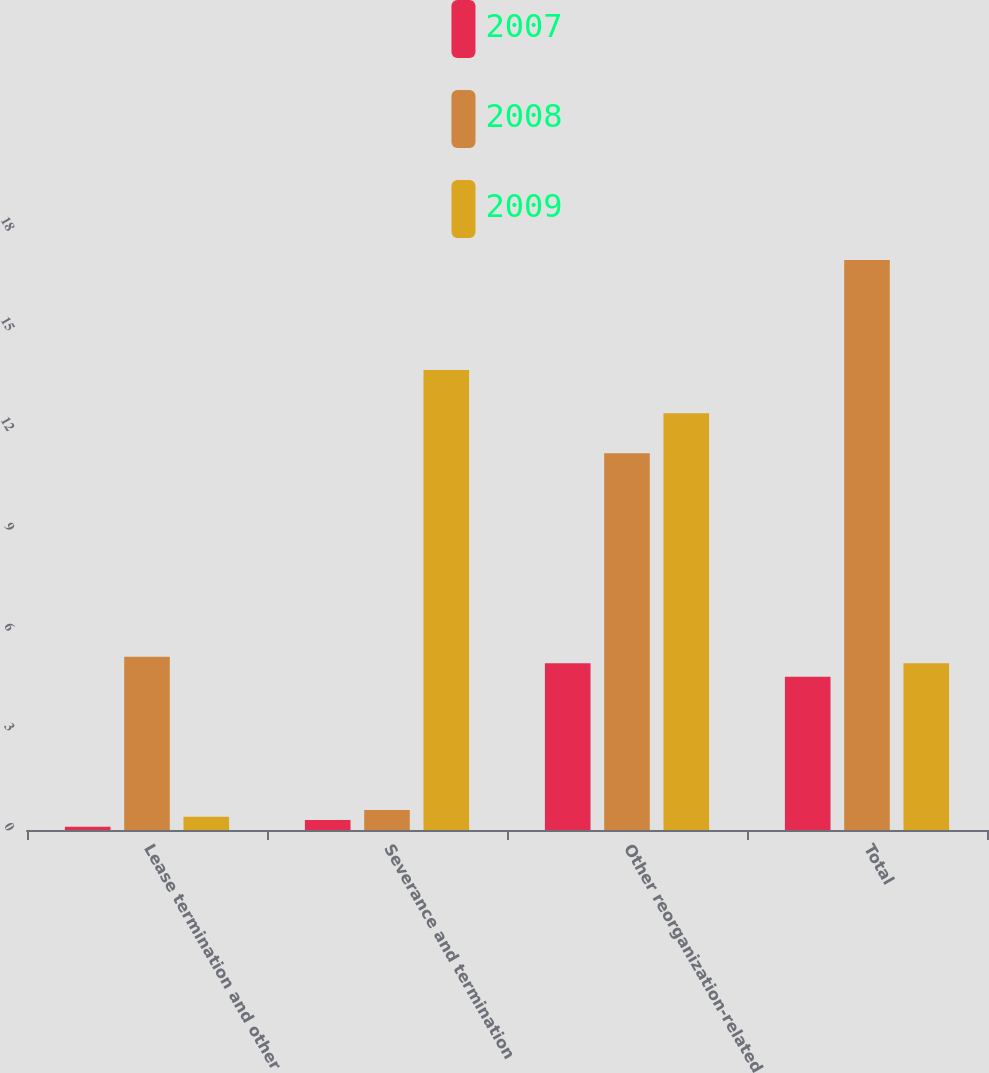Convert chart. <chart><loc_0><loc_0><loc_500><loc_500><stacked_bar_chart><ecel><fcel>Lease termination and other<fcel>Severance and termination<fcel>Other reorganization-related<fcel>Total<nl><fcel>2007<fcel>0.1<fcel>0.3<fcel>5<fcel>4.6<nl><fcel>2008<fcel>5.2<fcel>0.6<fcel>11.3<fcel>17.1<nl><fcel>2009<fcel>0.4<fcel>13.8<fcel>12.5<fcel>5<nl></chart> 